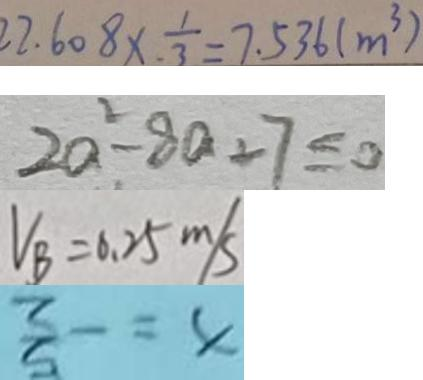Convert formula to latex. <formula><loc_0><loc_0><loc_500><loc_500>2 2 . 6 0 8 \times \frac { 1 } { 3 } = 7 . 5 3 6 ( m ^ { 3 } ) 
 2 a ^ { 2 } - 8 a + 7 \leq 0 
 V _ { B } = 0 . 2 5 m / s 
 x = - \frac { 5 } { 2 }</formula> 